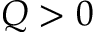Convert formula to latex. <formula><loc_0><loc_0><loc_500><loc_500>Q > 0</formula> 